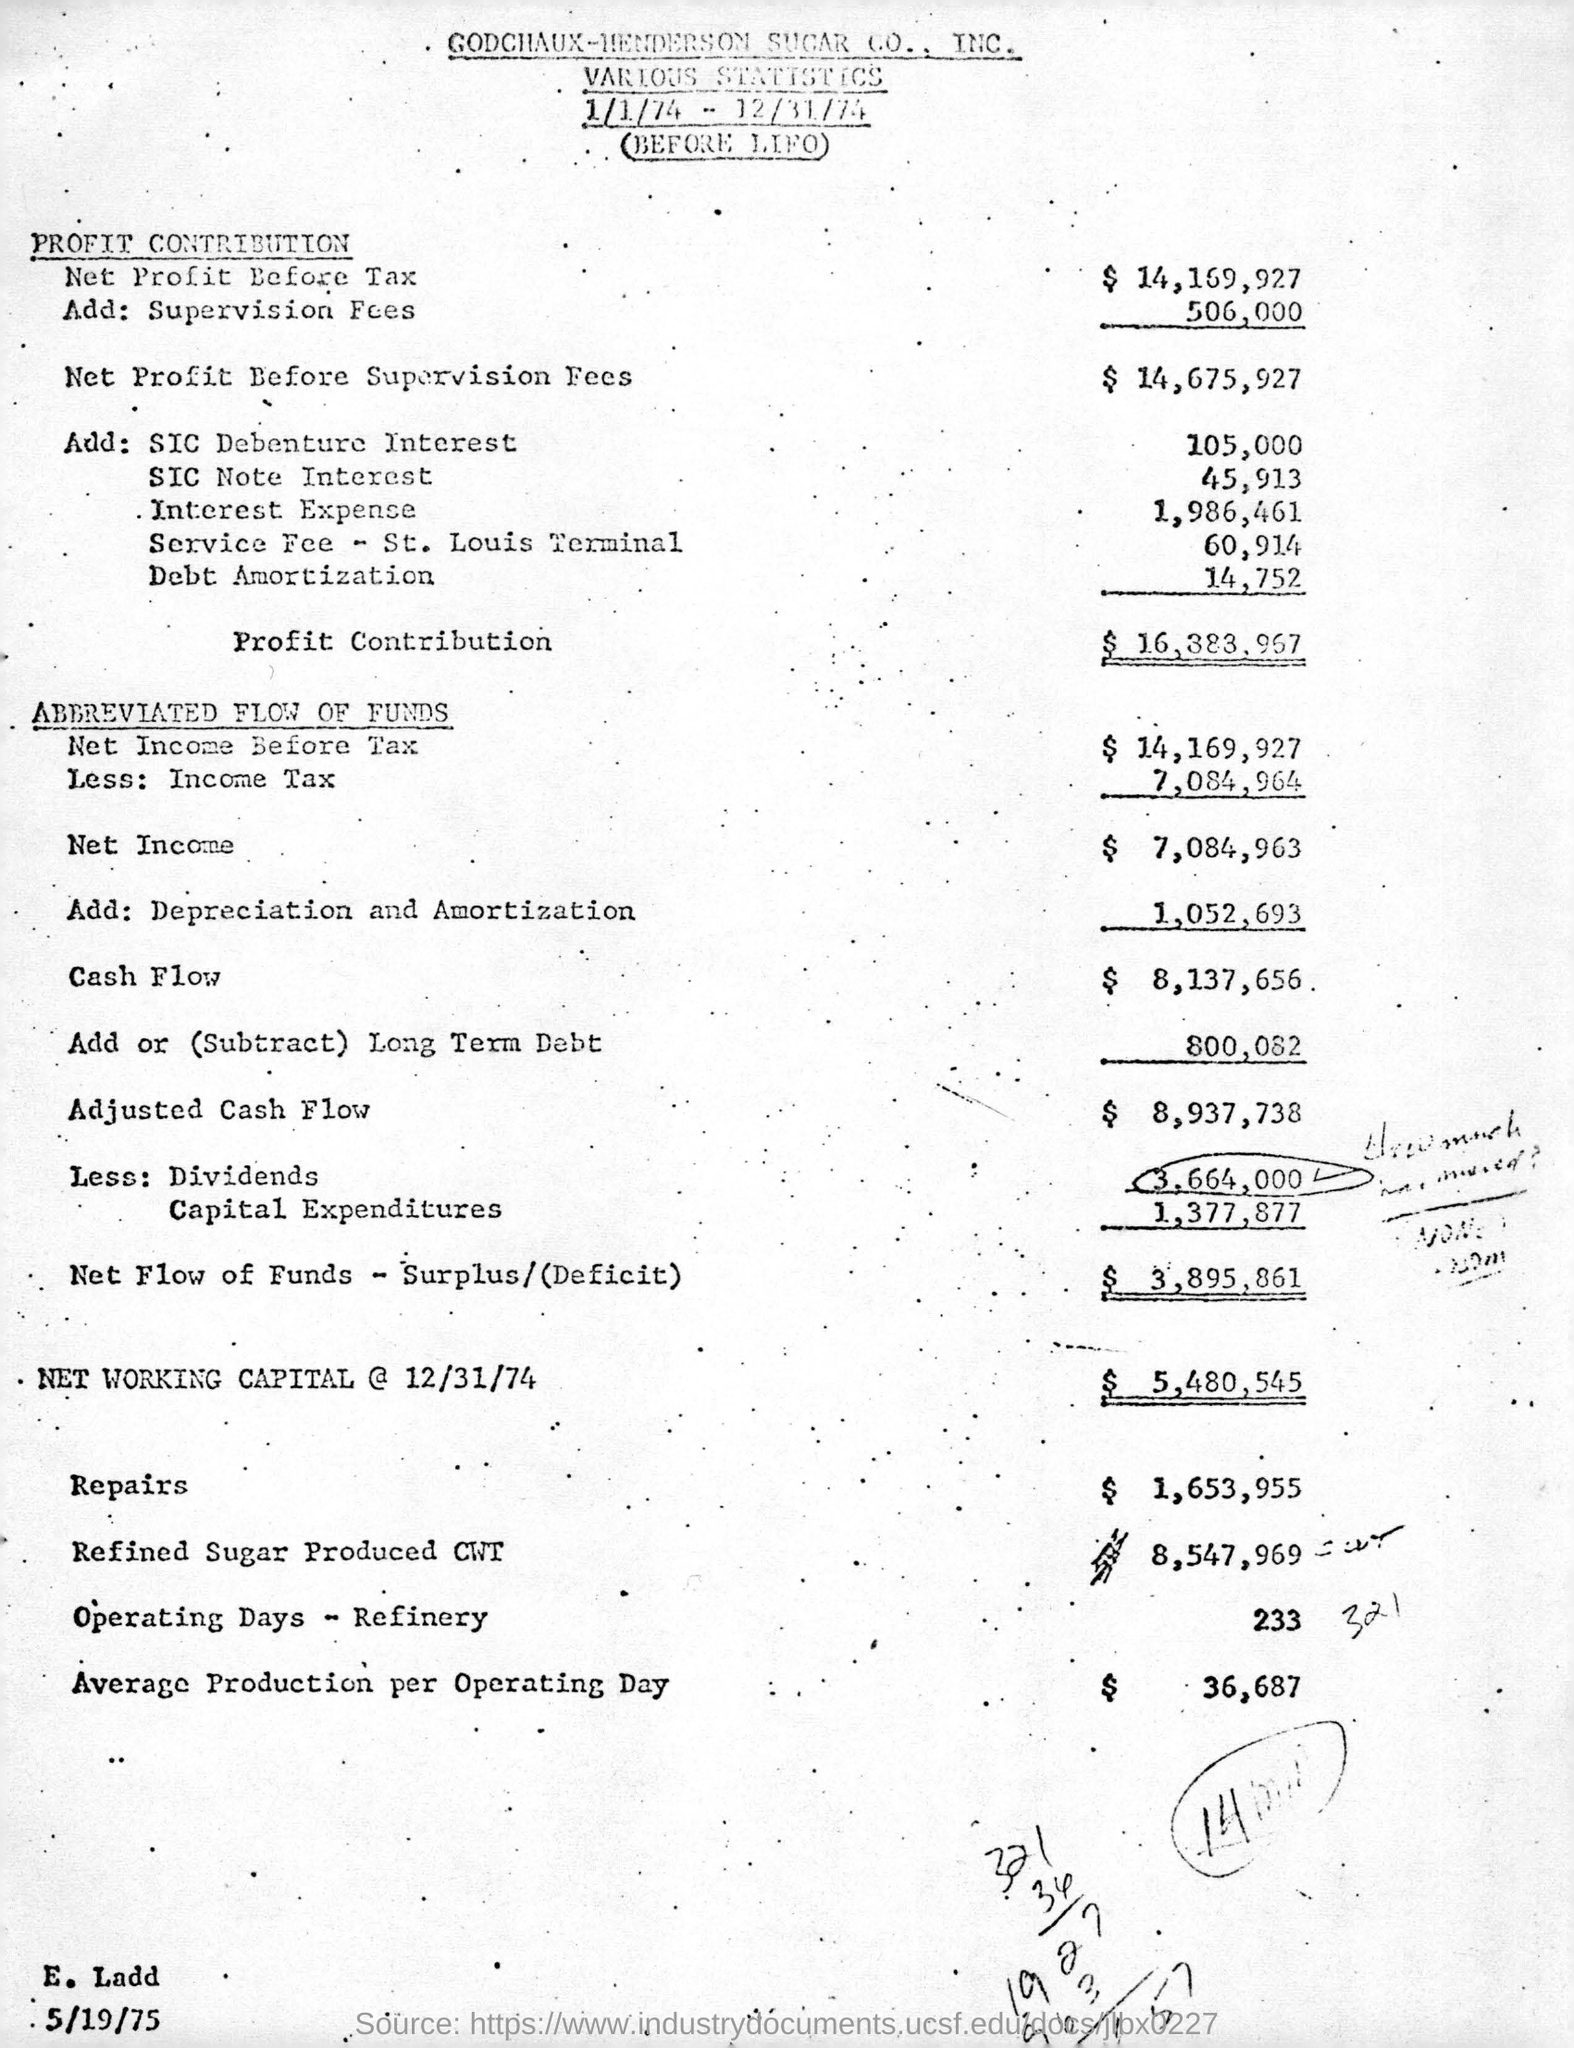Which company's statistics are this?
Offer a terse response. GODCHAUX-HENDERSOM SUGAR CO., INC. What is the Net Profit Before Tax?
Ensure brevity in your answer.  14,169,927. What is the total cost of Repairs?
Keep it short and to the point. $ 1,653,955. What is the Net Income?
Provide a short and direct response. $ 7,084,963. How many refinery operating days were there?
Your answer should be compact. 233. 